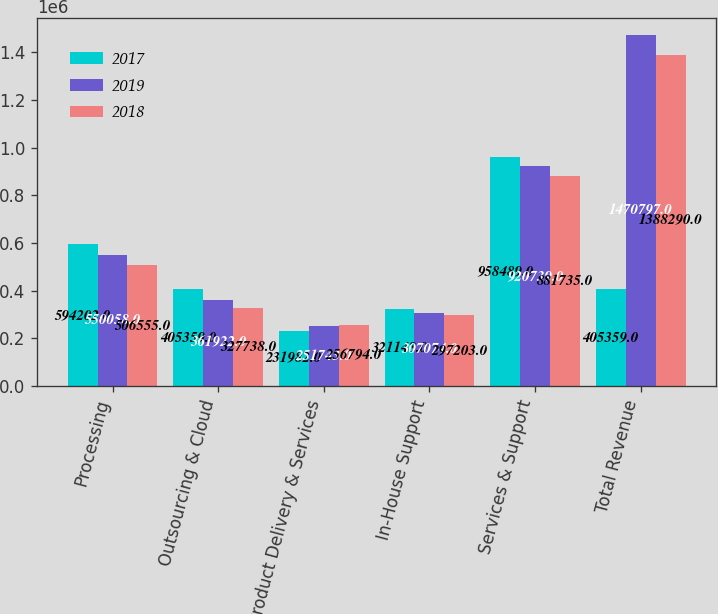Convert chart to OTSL. <chart><loc_0><loc_0><loc_500><loc_500><stacked_bar_chart><ecel><fcel>Processing<fcel>Outsourcing & Cloud<fcel>Product Delivery & Services<fcel>In-House Support<fcel>Services & Support<fcel>Total Revenue<nl><fcel>2017<fcel>594202<fcel>405359<fcel>231982<fcel>321148<fcel>958489<fcel>405359<nl><fcel>2019<fcel>550058<fcel>361922<fcel>251743<fcel>307074<fcel>920739<fcel>1.4708e+06<nl><fcel>2018<fcel>506555<fcel>327738<fcel>256794<fcel>297203<fcel>881735<fcel>1.38829e+06<nl></chart> 